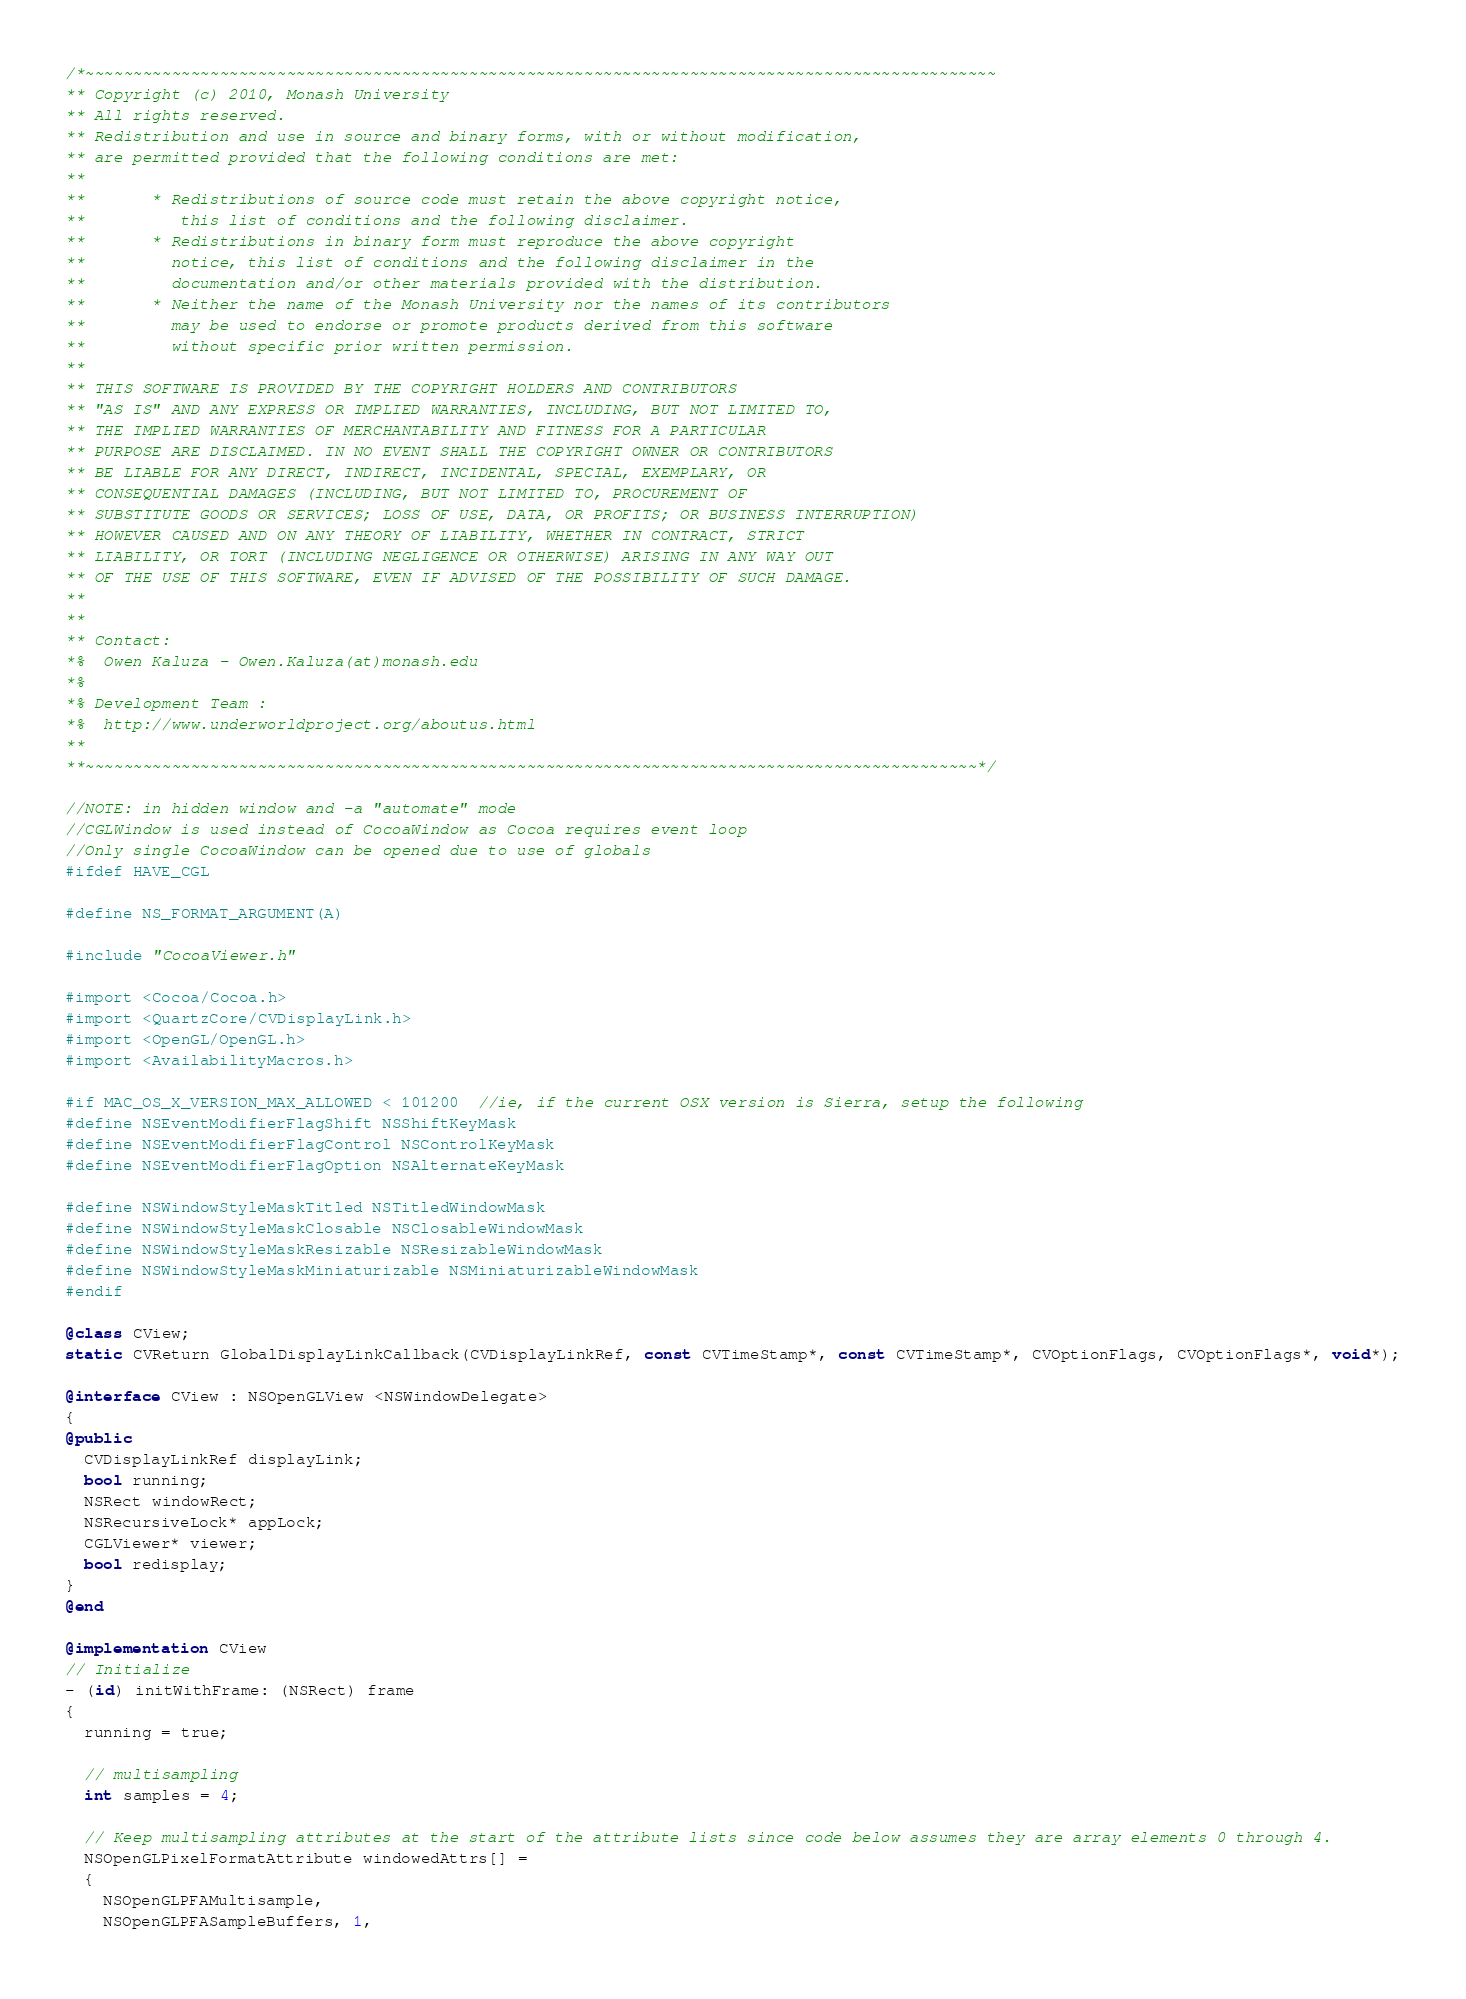Convert code to text. <code><loc_0><loc_0><loc_500><loc_500><_ObjectiveC_>/*~~~~~~~~~~~~~~~~~~~~~~~~~~~~~~~~~~~~~~~~~~~~~~~~~~~~~~~~~~~~~~~~~~~~~~~~~~~~~~~~~~~~~~~~~~~~~~~
** Copyright (c) 2010, Monash University
** All rights reserved.
** Redistribution and use in source and binary forms, with or without modification,
** are permitted provided that the following conditions are met:
**
**       * Redistributions of source code must retain the above copyright notice,
**          this list of conditions and the following disclaimer.
**       * Redistributions in binary form must reproduce the above copyright
**         notice, this list of conditions and the following disclaimer in the
**         documentation and/or other materials provided with the distribution.
**       * Neither the name of the Monash University nor the names of its contributors
**         may be used to endorse or promote products derived from this software
**         without specific prior written permission.
**
** THIS SOFTWARE IS PROVIDED BY THE COPYRIGHT HOLDERS AND CONTRIBUTORS
** "AS IS" AND ANY EXPRESS OR IMPLIED WARRANTIES, INCLUDING, BUT NOT LIMITED TO,
** THE IMPLIED WARRANTIES OF MERCHANTABILITY AND FITNESS FOR A PARTICULAR
** PURPOSE ARE DISCLAIMED. IN NO EVENT SHALL THE COPYRIGHT OWNER OR CONTRIBUTORS
** BE LIABLE FOR ANY DIRECT, INDIRECT, INCIDENTAL, SPECIAL, EXEMPLARY, OR
** CONSEQUENTIAL DAMAGES (INCLUDING, BUT NOT LIMITED TO, PROCUREMENT OF
** SUBSTITUTE GOODS OR SERVICES; LOSS OF USE, DATA, OR PROFITS; OR BUSINESS INTERRUPTION)
** HOWEVER CAUSED AND ON ANY THEORY OF LIABILITY, WHETHER IN CONTRACT, STRICT
** LIABILITY, OR TORT (INCLUDING NEGLIGENCE OR OTHERWISE) ARISING IN ANY WAY OUT
** OF THE USE OF THIS SOFTWARE, EVEN IF ADVISED OF THE POSSIBILITY OF SUCH DAMAGE.
**
**
** Contact:
*%  Owen Kaluza - Owen.Kaluza(at)monash.edu
*%
*% Development Team :
*%  http://www.underworldproject.org/aboutus.html
**
**~~~~~~~~~~~~~~~~~~~~~~~~~~~~~~~~~~~~~~~~~~~~~~~~~~~~~~~~~~~~~~~~~~~~~~~~~~~~~~~~~~~~~~~~~~~~~*/

//NOTE: in hidden window and -a "automate" mode
//CGLWindow is used instead of CocoaWindow as Cocoa requires event loop
//Only single CocoaWindow can be opened due to use of globals
#ifdef HAVE_CGL

#define NS_FORMAT_ARGUMENT(A)

#include "CocoaViewer.h"

#import <Cocoa/Cocoa.h>
#import <QuartzCore/CVDisplayLink.h>
#import <OpenGL/OpenGL.h>
#import <AvailabilityMacros.h>

#if MAC_OS_X_VERSION_MAX_ALLOWED < 101200  //ie, if the current OSX version is Sierra, setup the following
#define NSEventModifierFlagShift NSShiftKeyMask
#define NSEventModifierFlagControl NSControlKeyMask
#define NSEventModifierFlagOption NSAlternateKeyMask

#define NSWindowStyleMaskTitled NSTitledWindowMask
#define NSWindowStyleMaskClosable NSClosableWindowMask
#define NSWindowStyleMaskResizable NSResizableWindowMask
#define NSWindowStyleMaskMiniaturizable NSMiniaturizableWindowMask
#endif

@class CView;
static CVReturn GlobalDisplayLinkCallback(CVDisplayLinkRef, const CVTimeStamp*, const CVTimeStamp*, CVOptionFlags, CVOptionFlags*, void*);

@interface CView : NSOpenGLView <NSWindowDelegate>
{
@public
  CVDisplayLinkRef displayLink;
  bool running;
  NSRect windowRect;
  NSRecursiveLock* appLock;
  CGLViewer* viewer;
  bool redisplay;
}
@end

@implementation CView
// Initialize
- (id) initWithFrame: (NSRect) frame
{
  running = true;

  // multisampling
  int samples = 4;

  // Keep multisampling attributes at the start of the attribute lists since code below assumes they are array elements 0 through 4.
  NSOpenGLPixelFormatAttribute windowedAttrs[] =
  {
    NSOpenGLPFAMultisample,
    NSOpenGLPFASampleBuffers, 1,</code> 